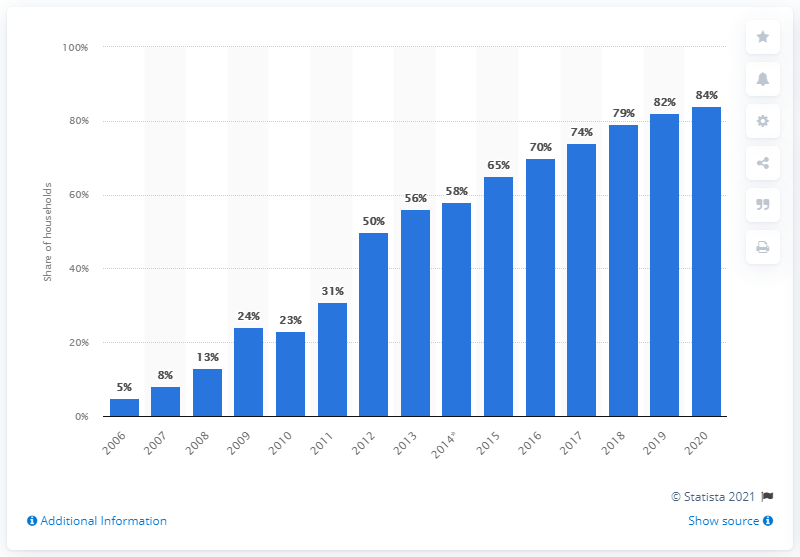Point out several critical features in this image. In 2020, approximately 84% of households in Romania had access to broadband internet. In 2020, there was a significant increase in broadband internet access in Romania, with a reported increase of 84%. 